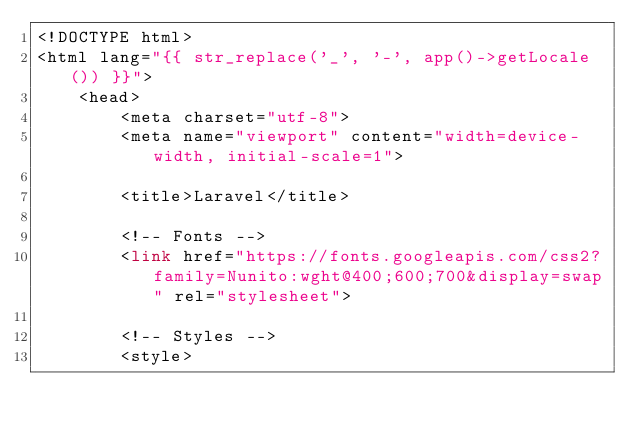<code> <loc_0><loc_0><loc_500><loc_500><_PHP_><!DOCTYPE html>
<html lang="{{ str_replace('_', '-', app()->getLocale()) }}">
    <head>
        <meta charset="utf-8">
        <meta name="viewport" content="width=device-width, initial-scale=1">

        <title>Laravel</title>

        <!-- Fonts -->
        <link href="https://fonts.googleapis.com/css2?family=Nunito:wght@400;600;700&display=swap" rel="stylesheet">

        <!-- Styles -->
        <style></code> 